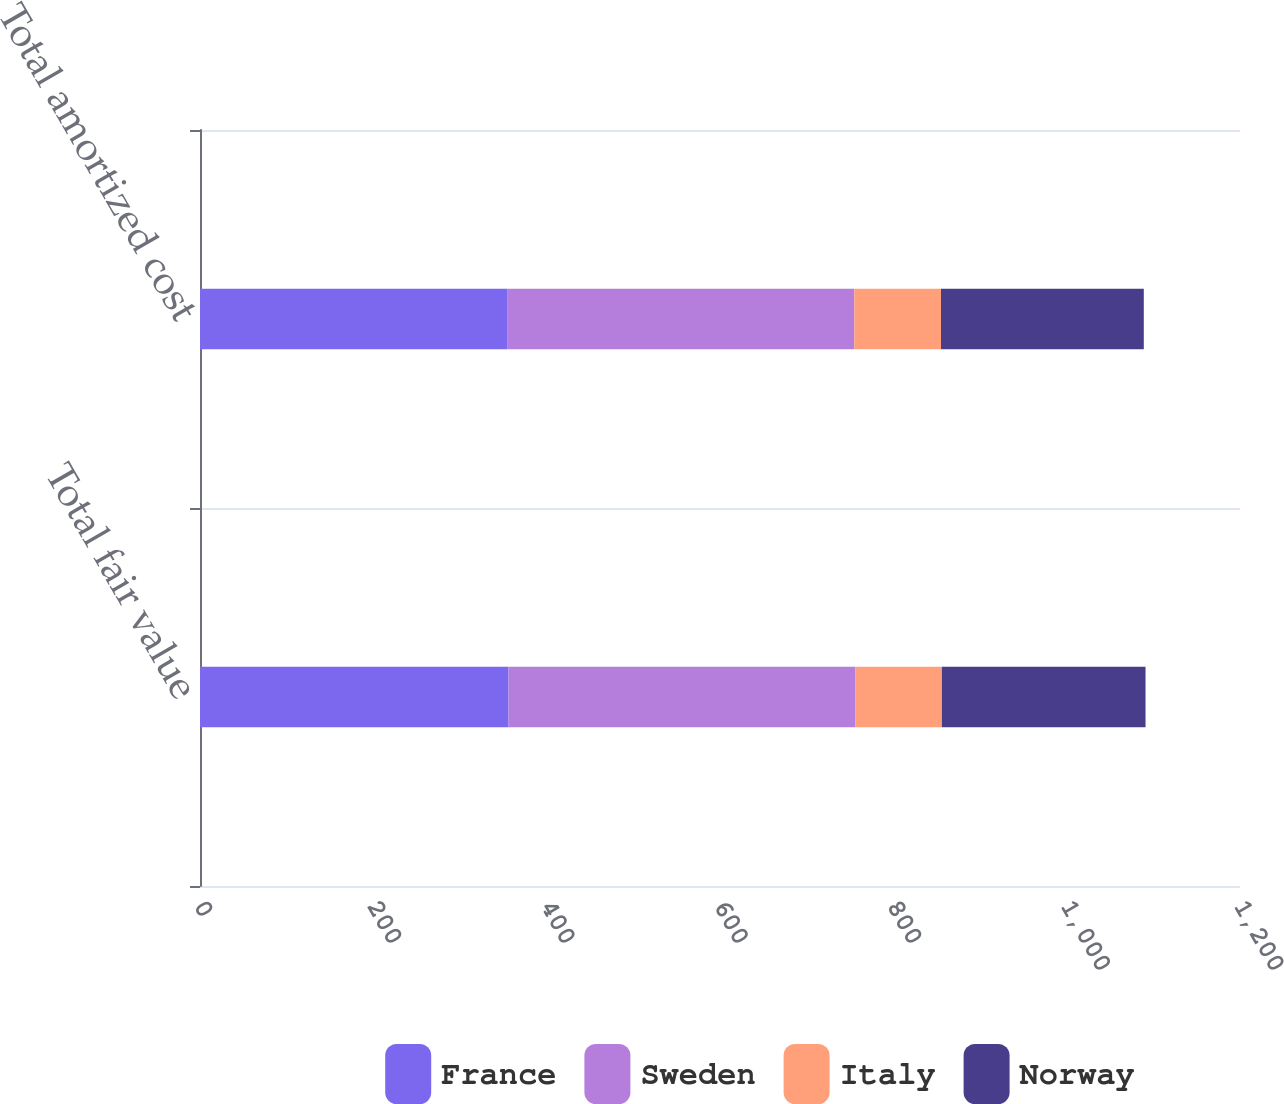Convert chart. <chart><loc_0><loc_0><loc_500><loc_500><stacked_bar_chart><ecel><fcel>Total fair value<fcel>Total amortized cost<nl><fcel>France<fcel>356<fcel>355<nl><fcel>Sweden<fcel>400<fcel>400<nl><fcel>Italy<fcel>100<fcel>100<nl><fcel>Norway<fcel>235<fcel>234<nl></chart> 